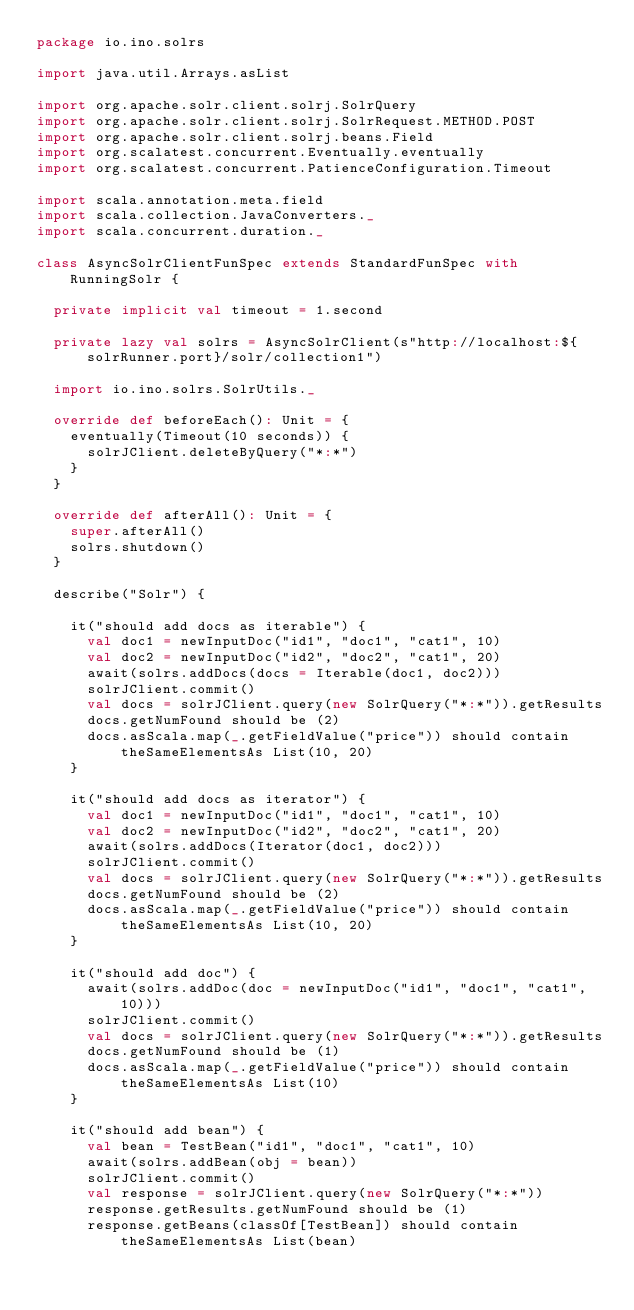Convert code to text. <code><loc_0><loc_0><loc_500><loc_500><_Scala_>package io.ino.solrs

import java.util.Arrays.asList

import org.apache.solr.client.solrj.SolrQuery
import org.apache.solr.client.solrj.SolrRequest.METHOD.POST
import org.apache.solr.client.solrj.beans.Field
import org.scalatest.concurrent.Eventually.eventually
import org.scalatest.concurrent.PatienceConfiguration.Timeout

import scala.annotation.meta.field
import scala.collection.JavaConverters._
import scala.concurrent.duration._

class AsyncSolrClientFunSpec extends StandardFunSpec with RunningSolr {

  private implicit val timeout = 1.second

  private lazy val solrs = AsyncSolrClient(s"http://localhost:${solrRunner.port}/solr/collection1")

  import io.ino.solrs.SolrUtils._

  override def beforeEach(): Unit = {
    eventually(Timeout(10 seconds)) {
      solrJClient.deleteByQuery("*:*")
    }
  }

  override def afterAll(): Unit = {
    super.afterAll()
    solrs.shutdown()
  }

  describe("Solr") {

    it("should add docs as iterable") {
      val doc1 = newInputDoc("id1", "doc1", "cat1", 10)
      val doc2 = newInputDoc("id2", "doc2", "cat1", 20)
      await(solrs.addDocs(docs = Iterable(doc1, doc2)))
      solrJClient.commit()
      val docs = solrJClient.query(new SolrQuery("*:*")).getResults
      docs.getNumFound should be (2)
      docs.asScala.map(_.getFieldValue("price")) should contain theSameElementsAs List(10, 20)
    }

    it("should add docs as iterator") {
      val doc1 = newInputDoc("id1", "doc1", "cat1", 10)
      val doc2 = newInputDoc("id2", "doc2", "cat1", 20)
      await(solrs.addDocs(Iterator(doc1, doc2)))
      solrJClient.commit()
      val docs = solrJClient.query(new SolrQuery("*:*")).getResults
      docs.getNumFound should be (2)
      docs.asScala.map(_.getFieldValue("price")) should contain theSameElementsAs List(10, 20)
    }

    it("should add doc") {
      await(solrs.addDoc(doc = newInputDoc("id1", "doc1", "cat1", 10)))
      solrJClient.commit()
      val docs = solrJClient.query(new SolrQuery("*:*")).getResults
      docs.getNumFound should be (1)
      docs.asScala.map(_.getFieldValue("price")) should contain theSameElementsAs List(10)
    }

    it("should add bean") {
      val bean = TestBean("id1", "doc1", "cat1", 10)
      await(solrs.addBean(obj = bean))
      solrJClient.commit()
      val response = solrJClient.query(new SolrQuery("*:*"))
      response.getResults.getNumFound should be (1)
      response.getBeans(classOf[TestBean]) should contain theSameElementsAs List(bean)</code> 